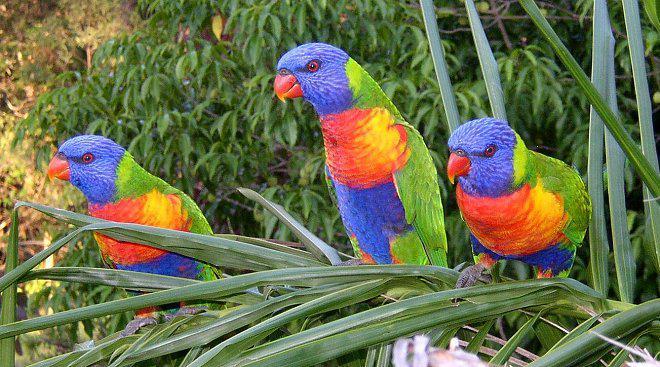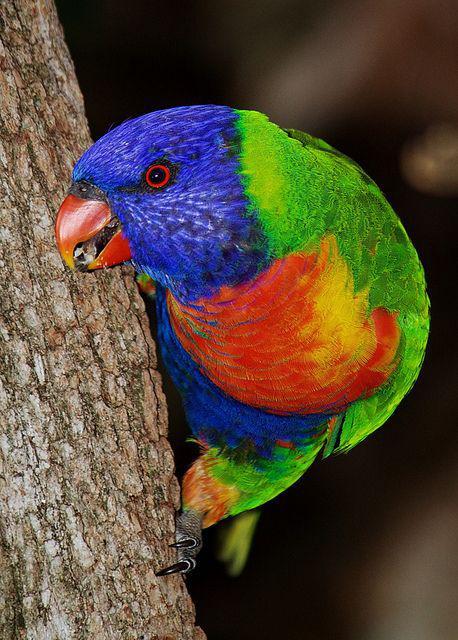The first image is the image on the left, the second image is the image on the right. Considering the images on both sides, is "There are no more than three birds" valid? Answer yes or no. No. The first image is the image on the left, the second image is the image on the right. Considering the images on both sides, is "In total, the images contain no more than three parrots." valid? Answer yes or no. No. 